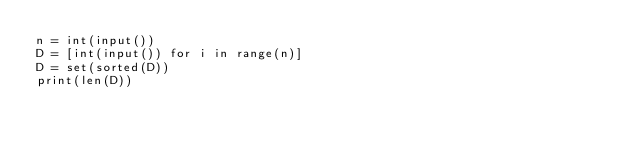Convert code to text. <code><loc_0><loc_0><loc_500><loc_500><_Python_>n = int(input())
D = [int(input()) for i in range(n)]
D = set(sorted(D))
print(len(D))
</code> 